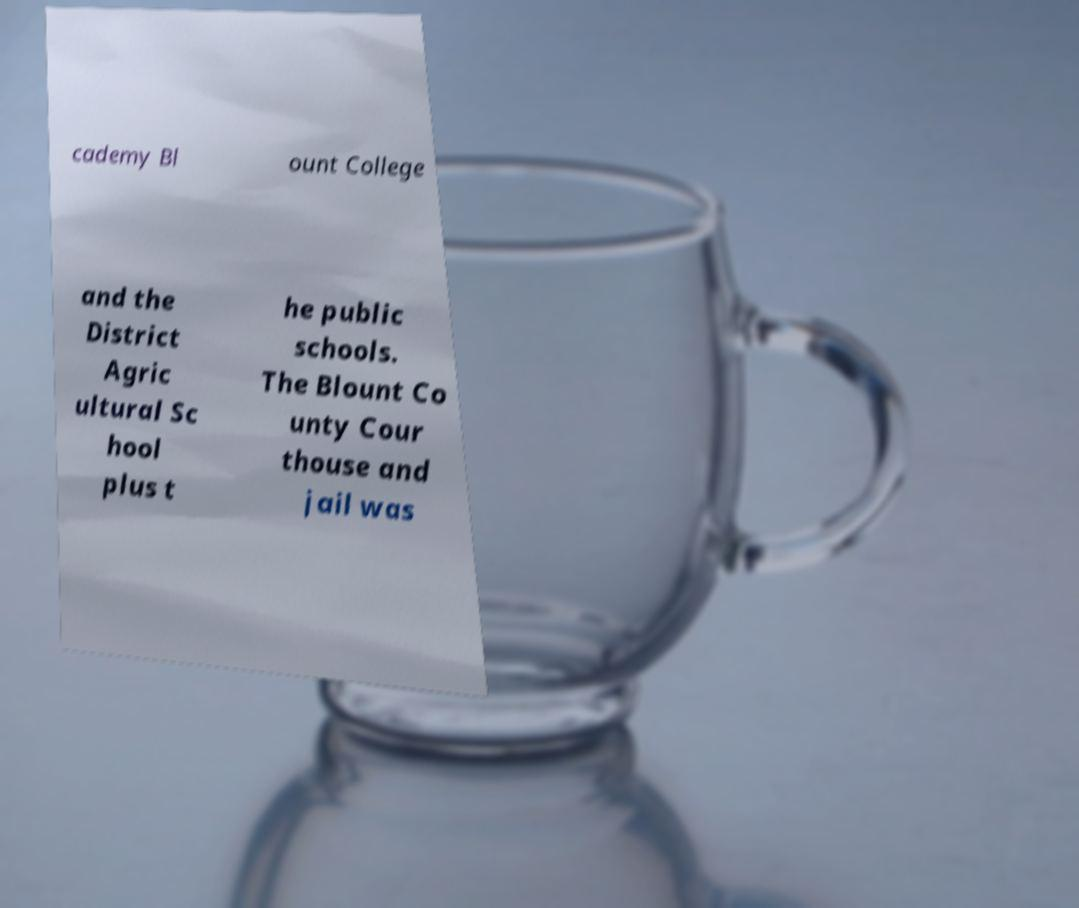Please read and relay the text visible in this image. What does it say? cademy Bl ount College and the District Agric ultural Sc hool plus t he public schools. The Blount Co unty Cour thouse and jail was 